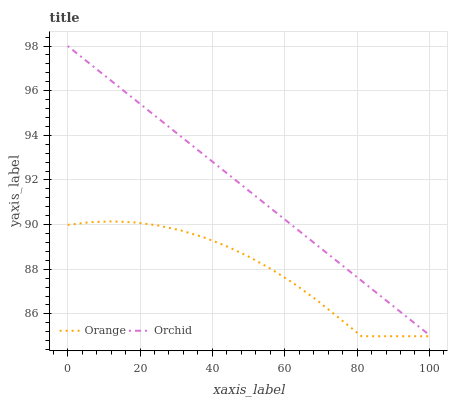Does Orchid have the minimum area under the curve?
Answer yes or no. No. Is Orchid the roughest?
Answer yes or no. No. Does Orchid have the lowest value?
Answer yes or no. No. Is Orange less than Orchid?
Answer yes or no. Yes. Is Orchid greater than Orange?
Answer yes or no. Yes. Does Orange intersect Orchid?
Answer yes or no. No. 